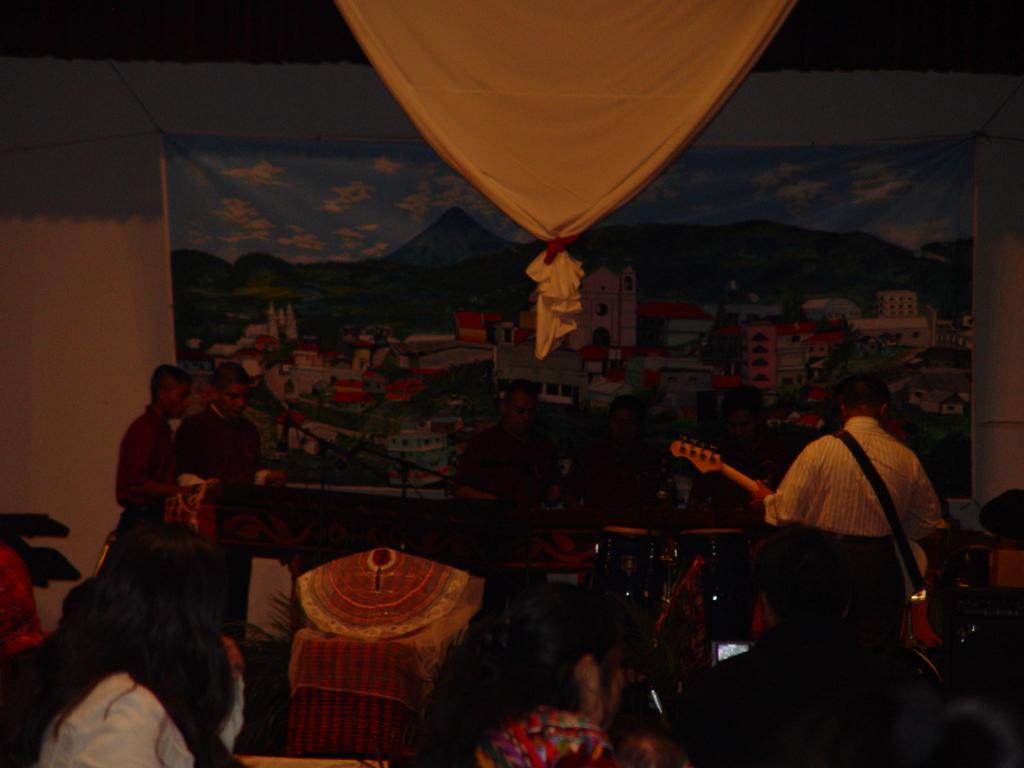Please provide a concise description of this image. In this image there are few people sat on their chairs, in front of them there are few people playing a musical instrument. In the background there is a banner. At the top of the image there is a curtain. 